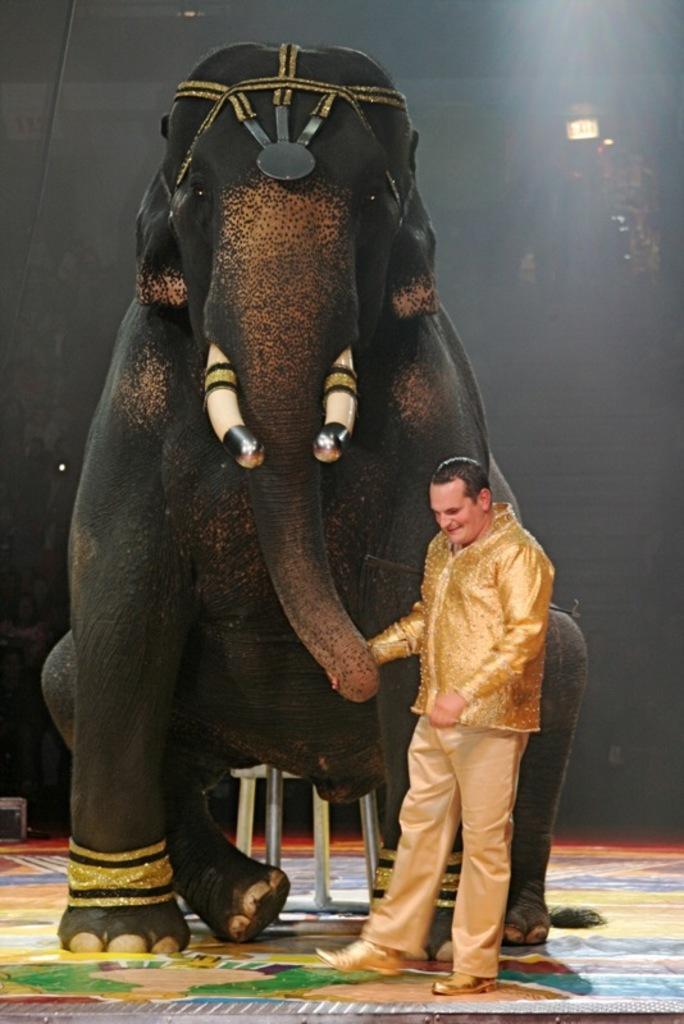Please provide a concise description of this image. In this picture we can see an elephant. And there is a man. 